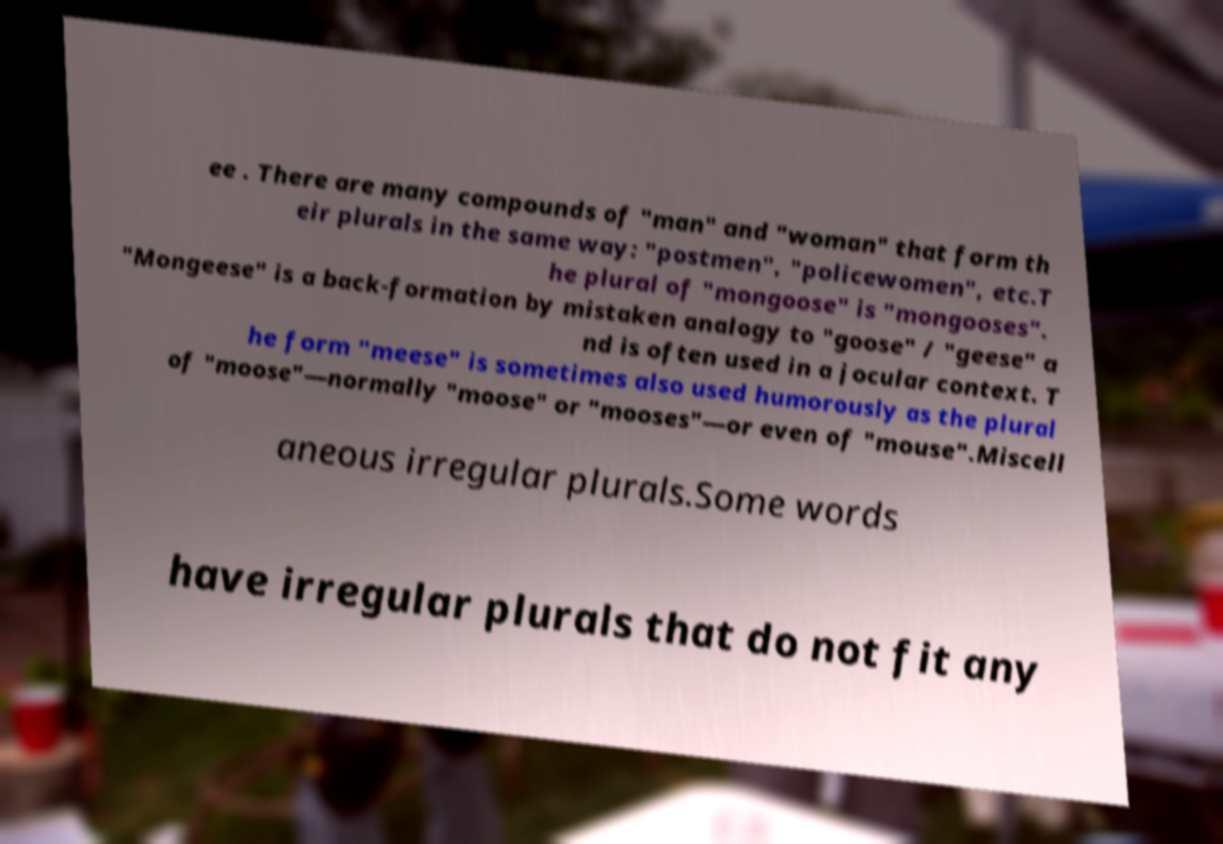For documentation purposes, I need the text within this image transcribed. Could you provide that? ee . There are many compounds of "man" and "woman" that form th eir plurals in the same way: "postmen", "policewomen", etc.T he plural of "mongoose" is "mongooses". "Mongeese" is a back-formation by mistaken analogy to "goose" / "geese" a nd is often used in a jocular context. T he form "meese" is sometimes also used humorously as the plural of "moose"—normally "moose" or "mooses"—or even of "mouse".Miscell aneous irregular plurals.Some words have irregular plurals that do not fit any 